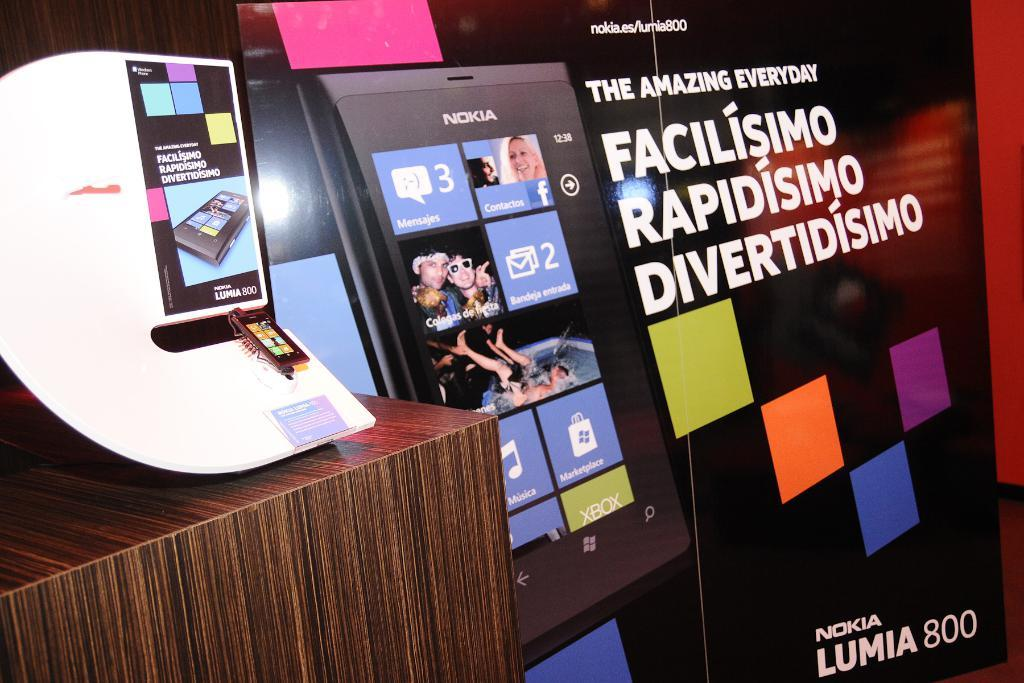<image>
Create a compact narrative representing the image presented. ad poster for the nokia lumia 800 cell phone 